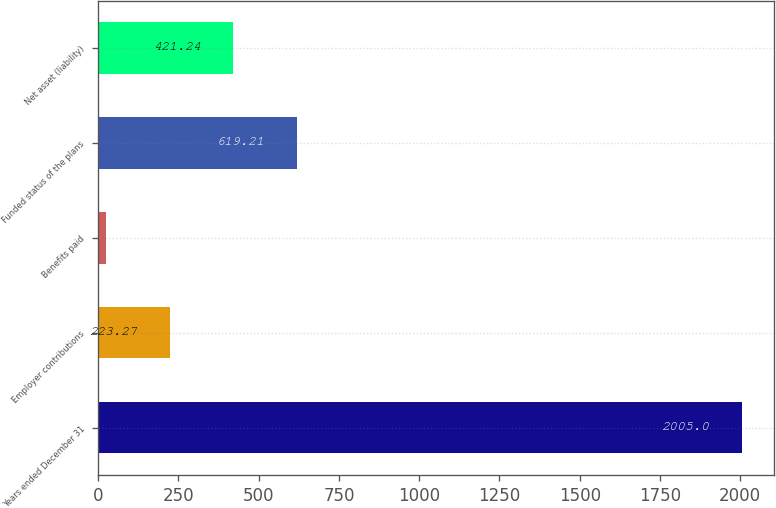<chart> <loc_0><loc_0><loc_500><loc_500><bar_chart><fcel>Years ended December 31<fcel>Employer contributions<fcel>Benefits paid<fcel>Funded status of the plans<fcel>Net asset (liability)<nl><fcel>2005<fcel>223.27<fcel>25.3<fcel>619.21<fcel>421.24<nl></chart> 